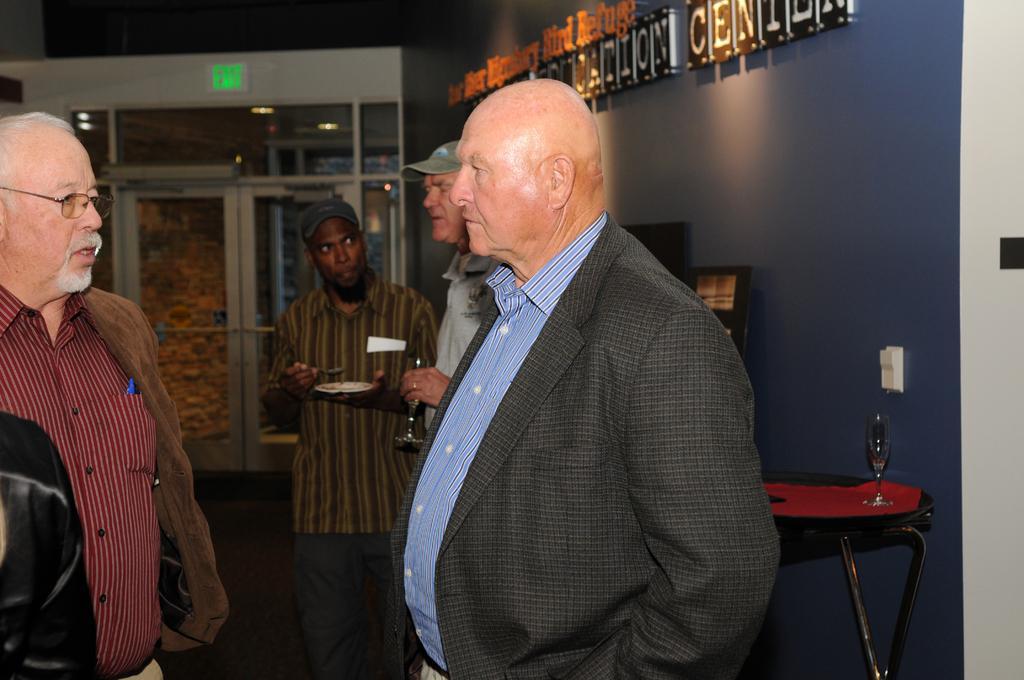Could you give a brief overview of what you see in this image? In this image, there are four people standing. Among them two people are holding the objects. On the right side of the image, I can see a name board attached to the wall and a wine glass on the table. In the background, there is a glass door and an exit board. 